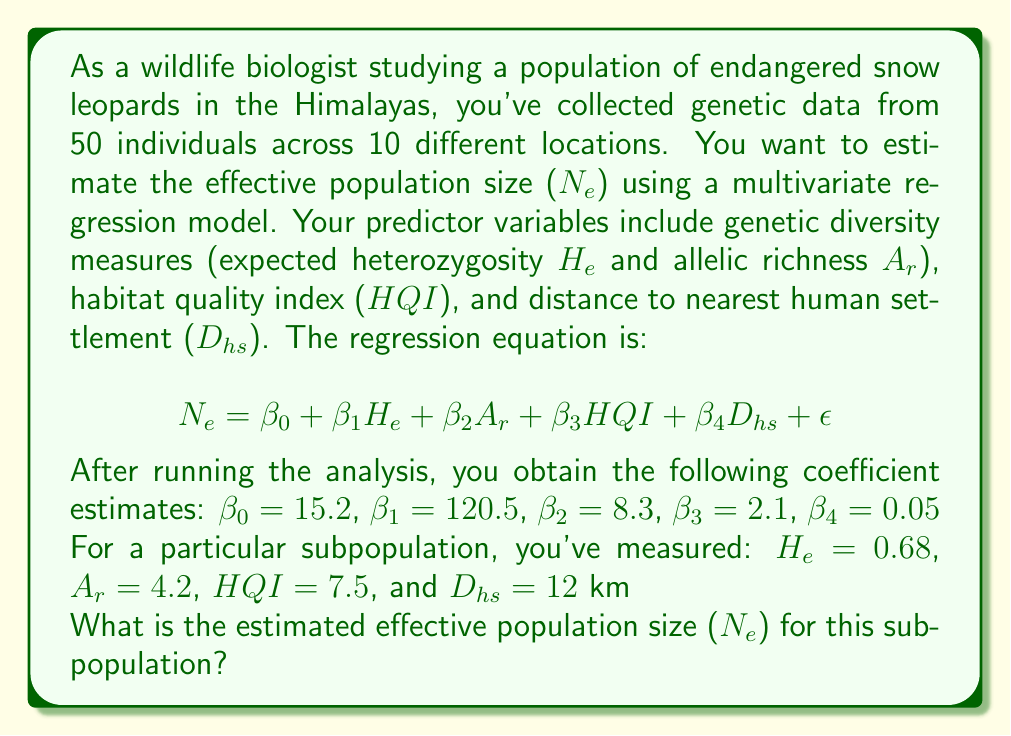Can you solve this math problem? To solve this problem, we need to use the multivariate regression equation provided and plug in the given values. Let's break it down step by step:

1. Recall the regression equation:
   $$N_e = \beta_0 + \beta_1H_e + \beta_2A_r + \beta_3HQI + \beta_4D_{hs} + \epsilon$$

2. We're given the following coefficient estimates:
   $\beta_0 = 15.2$ (intercept)
   $\beta_1 = 120.5$ (coefficient for $H_e$)
   $\beta_2 = 8.3$ (coefficient for $A_r$)
   $\beta_3 = 2.1$ (coefficient for $HQI$)
   $\beta_4 = 0.05$ (coefficient for $D_{hs}$)

3. For the subpopulation in question, we have these measurements:
   $H_e = 0.68$
   $A_r = 4.2$
   $HQI = 7.5$
   $D_{hs} = 12$ km

4. Now, let's substitute these values into the equation:
   $$N_e = 15.2 + 120.5(0.68) + 8.3(4.2) + 2.1(7.5) + 0.05(12)$$

5. Let's calculate each term:
   - $15.2$ (intercept)
   - $120.5 * 0.68 = 81.94$
   - $8.3 * 4.2 = 34.86$
   - $2.1 * 7.5 = 15.75$
   - $0.05 * 12 = 0.6$

6. Sum up all the terms:
   $$N_e = 15.2 + 81.94 + 34.86 + 15.75 + 0.6$$

7. Calculate the final result:
   $$N_e = 148.35$$

8. Since we're estimating a population size, we should round to the nearest whole number:
   $$N_e \approx 148$$

Therefore, the estimated effective population size for this subpopulation of snow leopards is approximately 148 individuals.
Answer: The estimated effective population size ($N_e$) for this subpopulation is approximately 148 individuals. 